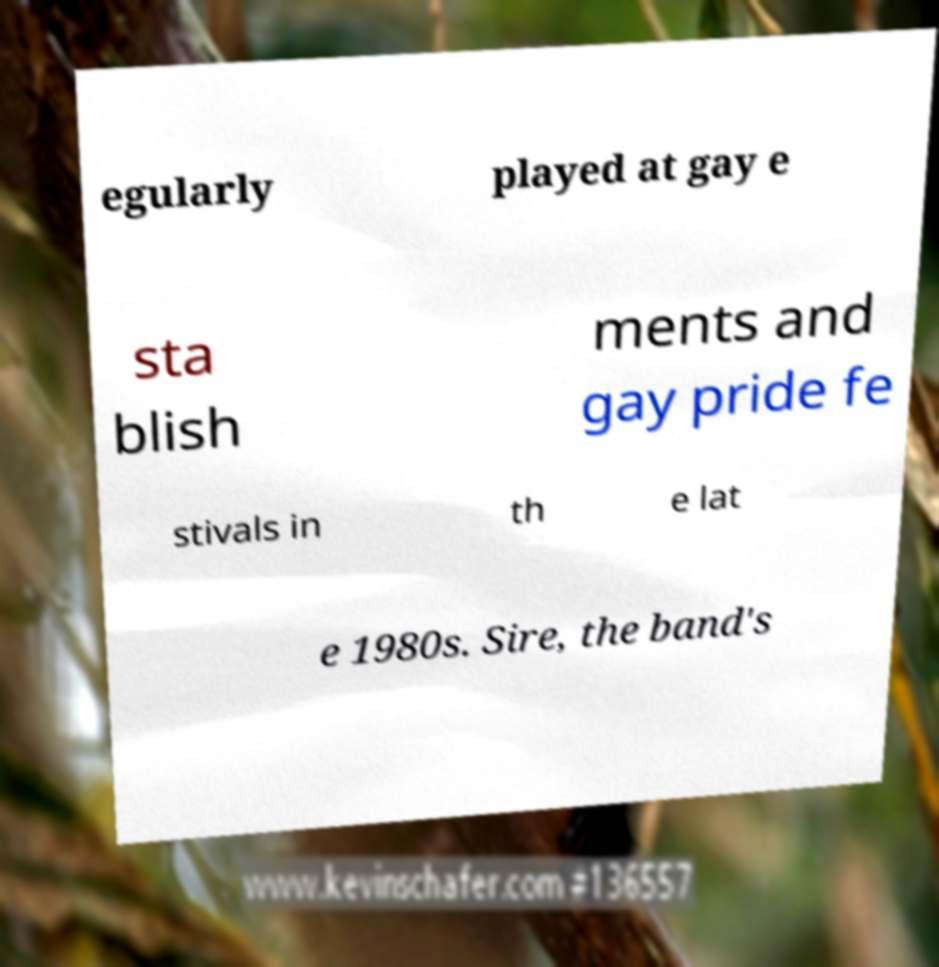Can you accurately transcribe the text from the provided image for me? egularly played at gay e sta blish ments and gay pride fe stivals in th e lat e 1980s. Sire, the band's 